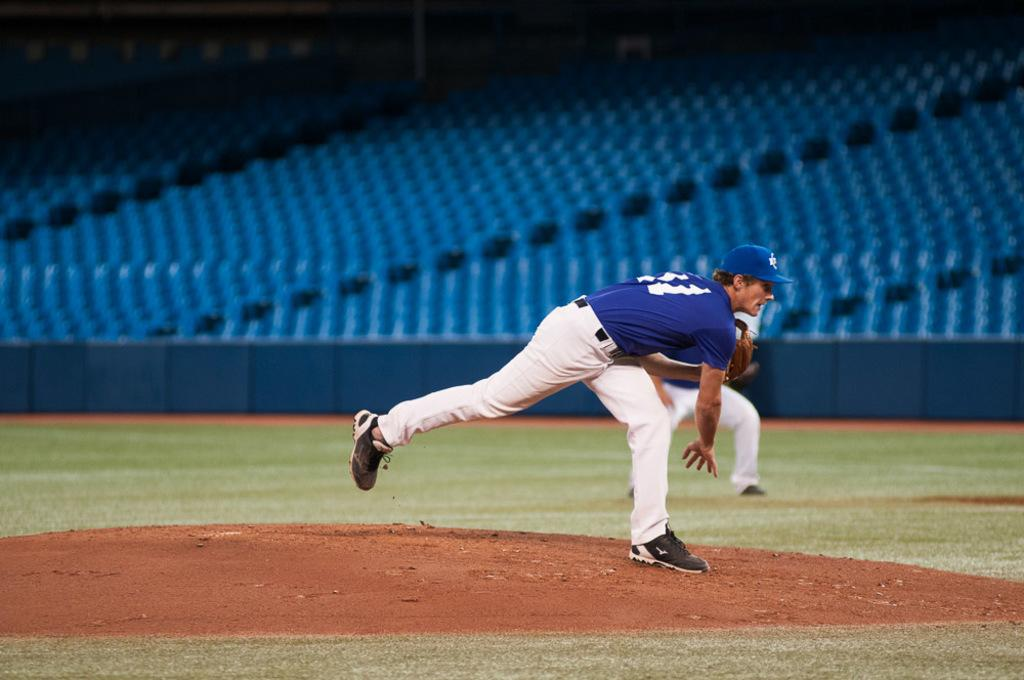Where was the image taken? The image was taken in a playground. How many people are in the image? There are two persons in the image. What can be seen in the background of the image? There are chairs in the background of the image. What color is the fence in the image? The fence in the image is blue. What type of pancake is the daughter eating in the image? There is no pancake or daughter present in the image. How many eyes does the person on the left have in the image? The image does not show the eyes of the persons, so it cannot be determined from the image. 